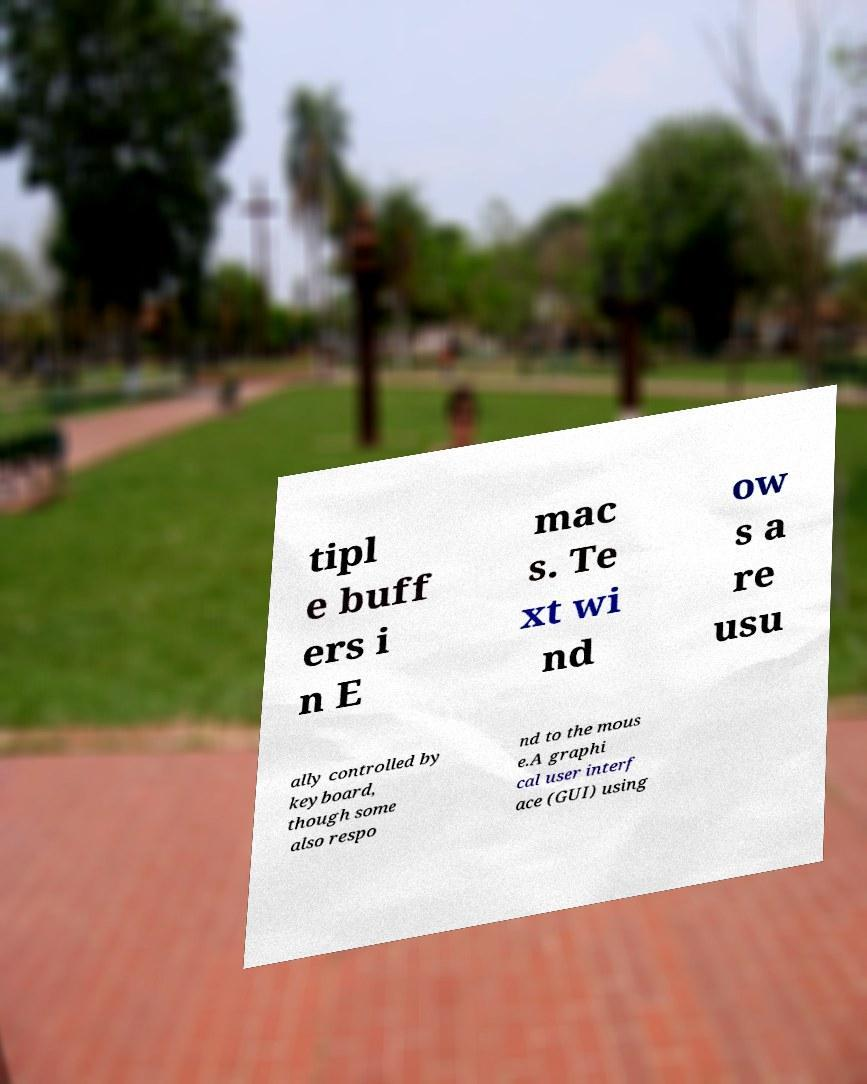Please read and relay the text visible in this image. What does it say? tipl e buff ers i n E mac s. Te xt wi nd ow s a re usu ally controlled by keyboard, though some also respo nd to the mous e.A graphi cal user interf ace (GUI) using 